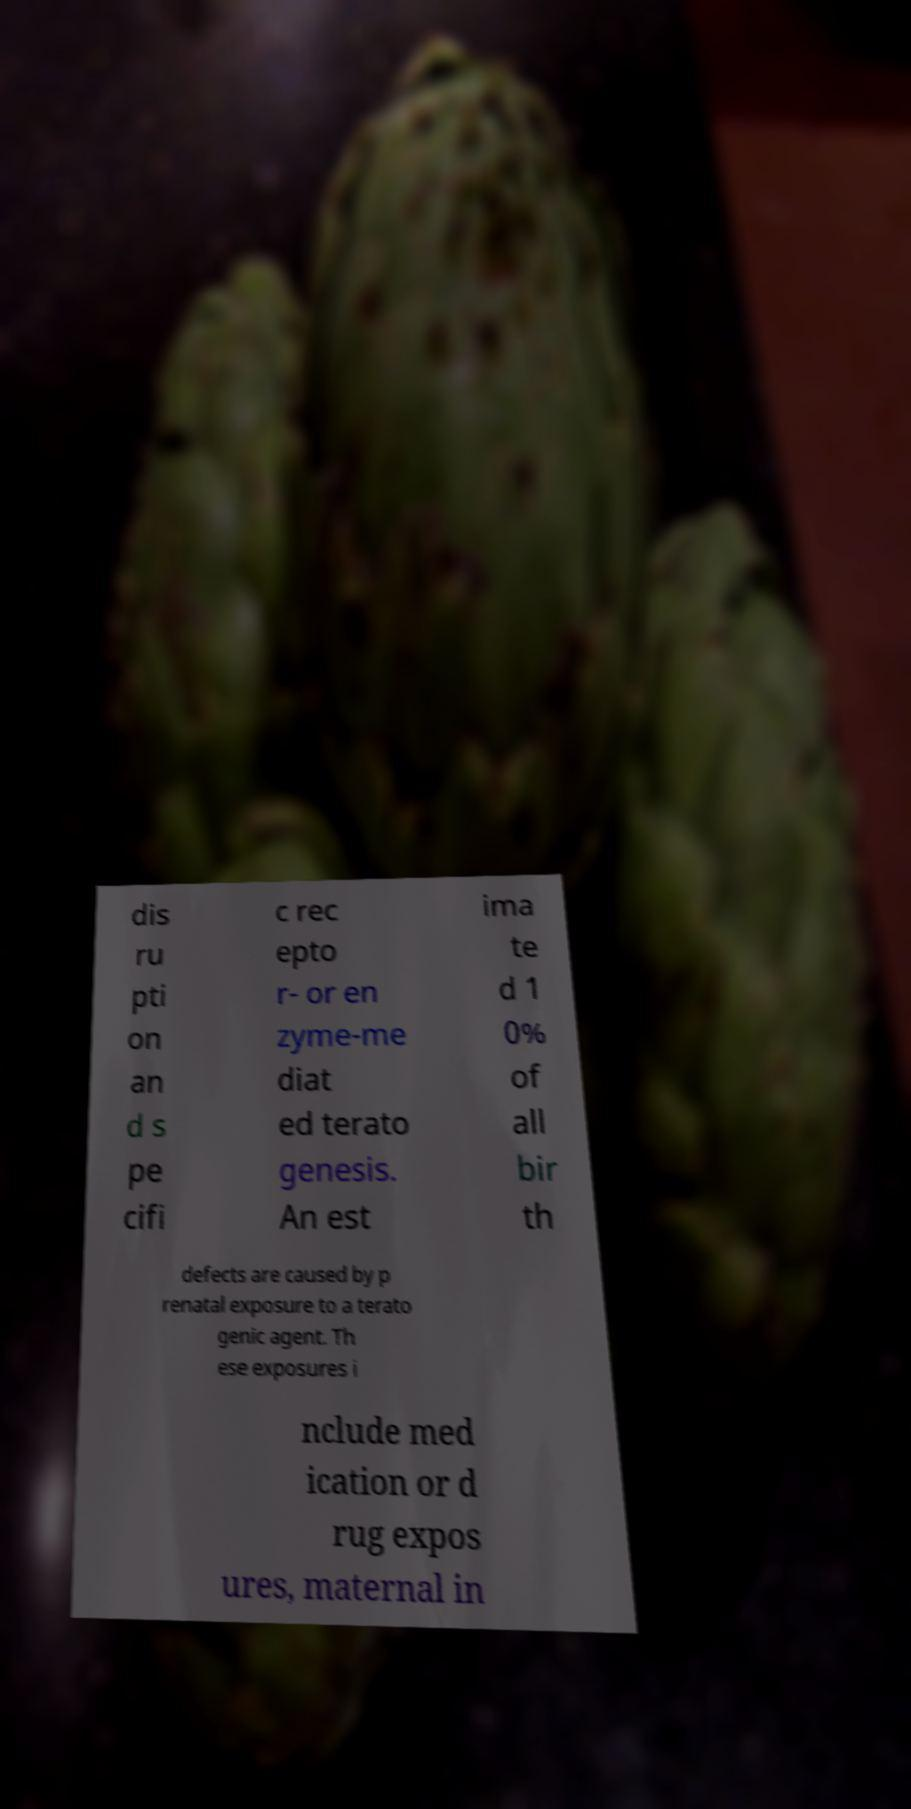Please read and relay the text visible in this image. What does it say? dis ru pti on an d s pe cifi c rec epto r- or en zyme-me diat ed terato genesis. An est ima te d 1 0% of all bir th defects are caused by p renatal exposure to a terato genic agent. Th ese exposures i nclude med ication or d rug expos ures, maternal in 